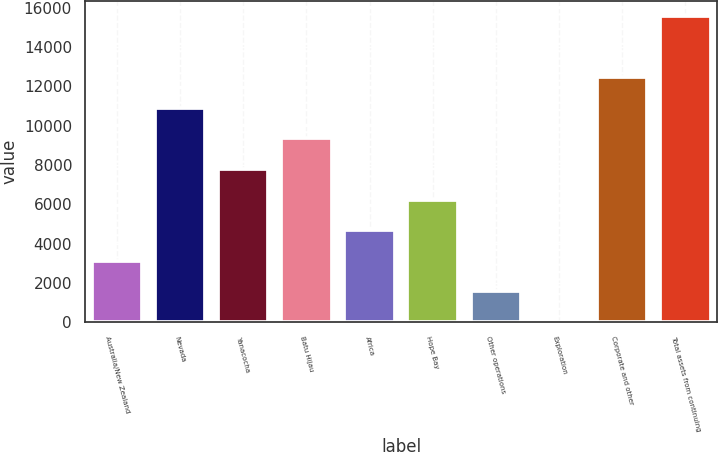<chart> <loc_0><loc_0><loc_500><loc_500><bar_chart><fcel>Australia/New Zealand<fcel>Nevada<fcel>Yanacocha<fcel>Batu Hijau<fcel>Africa<fcel>Hope Bay<fcel>Other operations<fcel>Exploration<fcel>Corporate and other<fcel>Total assets from continuing<nl><fcel>3134<fcel>10909<fcel>7799<fcel>9354<fcel>4689<fcel>6244<fcel>1579<fcel>24<fcel>12464<fcel>15574<nl></chart> 